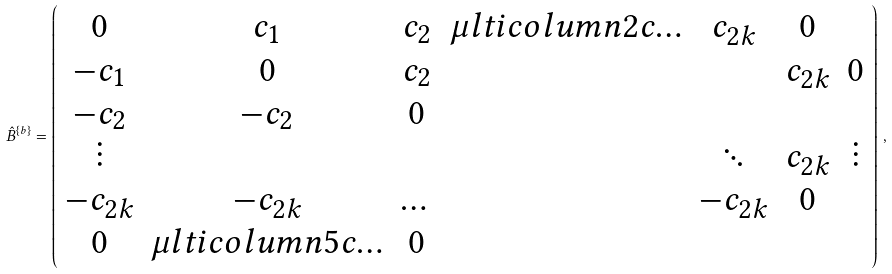<formula> <loc_0><loc_0><loc_500><loc_500>\hat { B } ^ { \left \{ { b } \right \} } = \left ( \begin{array} { c c c c c c c } 0 & c _ { 1 } & c _ { 2 } & \mu l t i c o l u m n { 2 } { c } { \dots } & c _ { 2 k } & 0 \\ - c _ { 1 } & 0 & c _ { 2 } & & & c _ { 2 k } & 0 \\ - c _ { 2 } & - c _ { 2 } & 0 & & & & \\ \vdots & & & & \ddots & c _ { 2 k } & \vdots \\ - c _ { 2 k } & - c _ { 2 k } & \dots & & - c _ { 2 k } & 0 & \\ 0 & \mu l t i c o l u m n { 5 } { c } { \dots } & 0 \\ \end{array} \right ) \, ,</formula> 